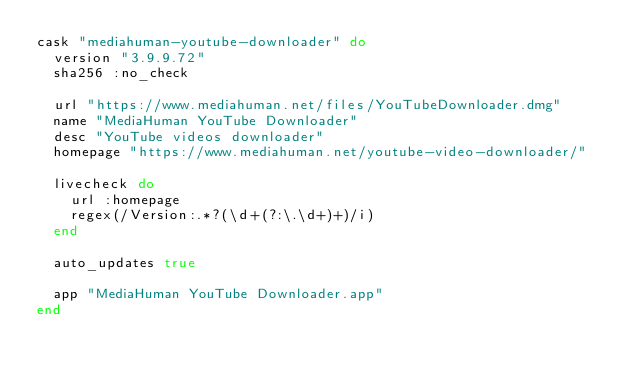<code> <loc_0><loc_0><loc_500><loc_500><_Ruby_>cask "mediahuman-youtube-downloader" do
  version "3.9.9.72"
  sha256 :no_check

  url "https://www.mediahuman.net/files/YouTubeDownloader.dmg"
  name "MediaHuman YouTube Downloader"
  desc "YouTube videos downloader"
  homepage "https://www.mediahuman.net/youtube-video-downloader/"

  livecheck do
    url :homepage
    regex(/Version:.*?(\d+(?:\.\d+)+)/i)
  end

  auto_updates true

  app "MediaHuman YouTube Downloader.app"
end
</code> 